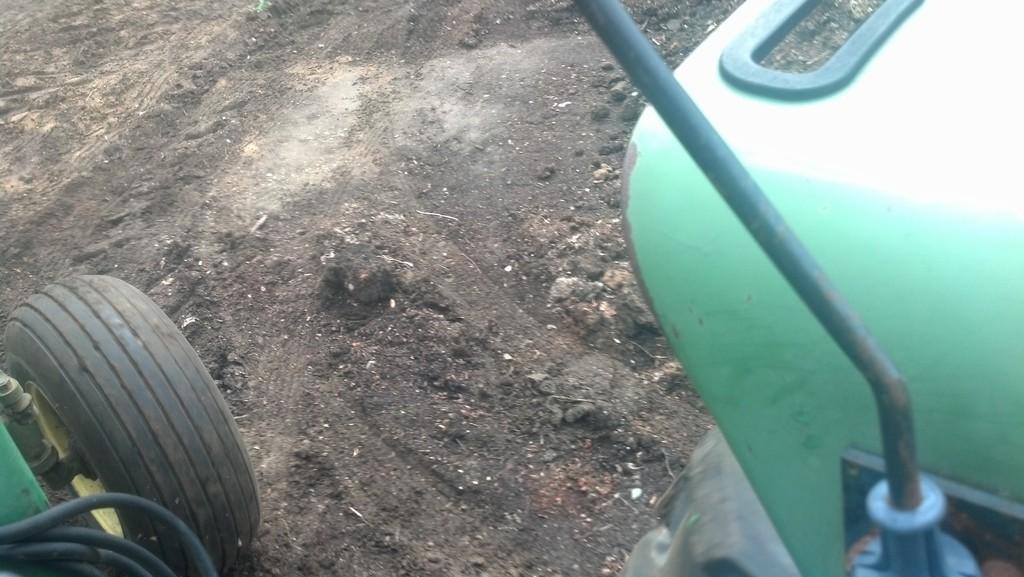Describe this image in one or two sentences. In this image, I can see a vehicle with a wheel on the ground. 